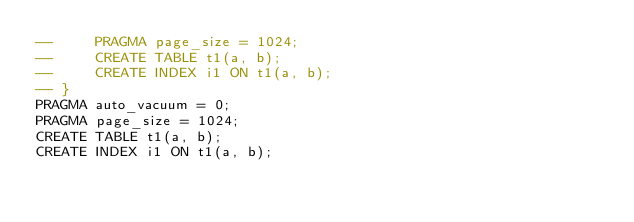Convert code to text. <code><loc_0><loc_0><loc_500><loc_500><_SQL_>--     PRAGMA page_size = 1024;
--     CREATE TABLE t1(a, b);
--     CREATE INDEX i1 ON t1(a, b);
-- }
PRAGMA auto_vacuum = 0;
PRAGMA page_size = 1024;
CREATE TABLE t1(a, b);
CREATE INDEX i1 ON t1(a, b);</code> 